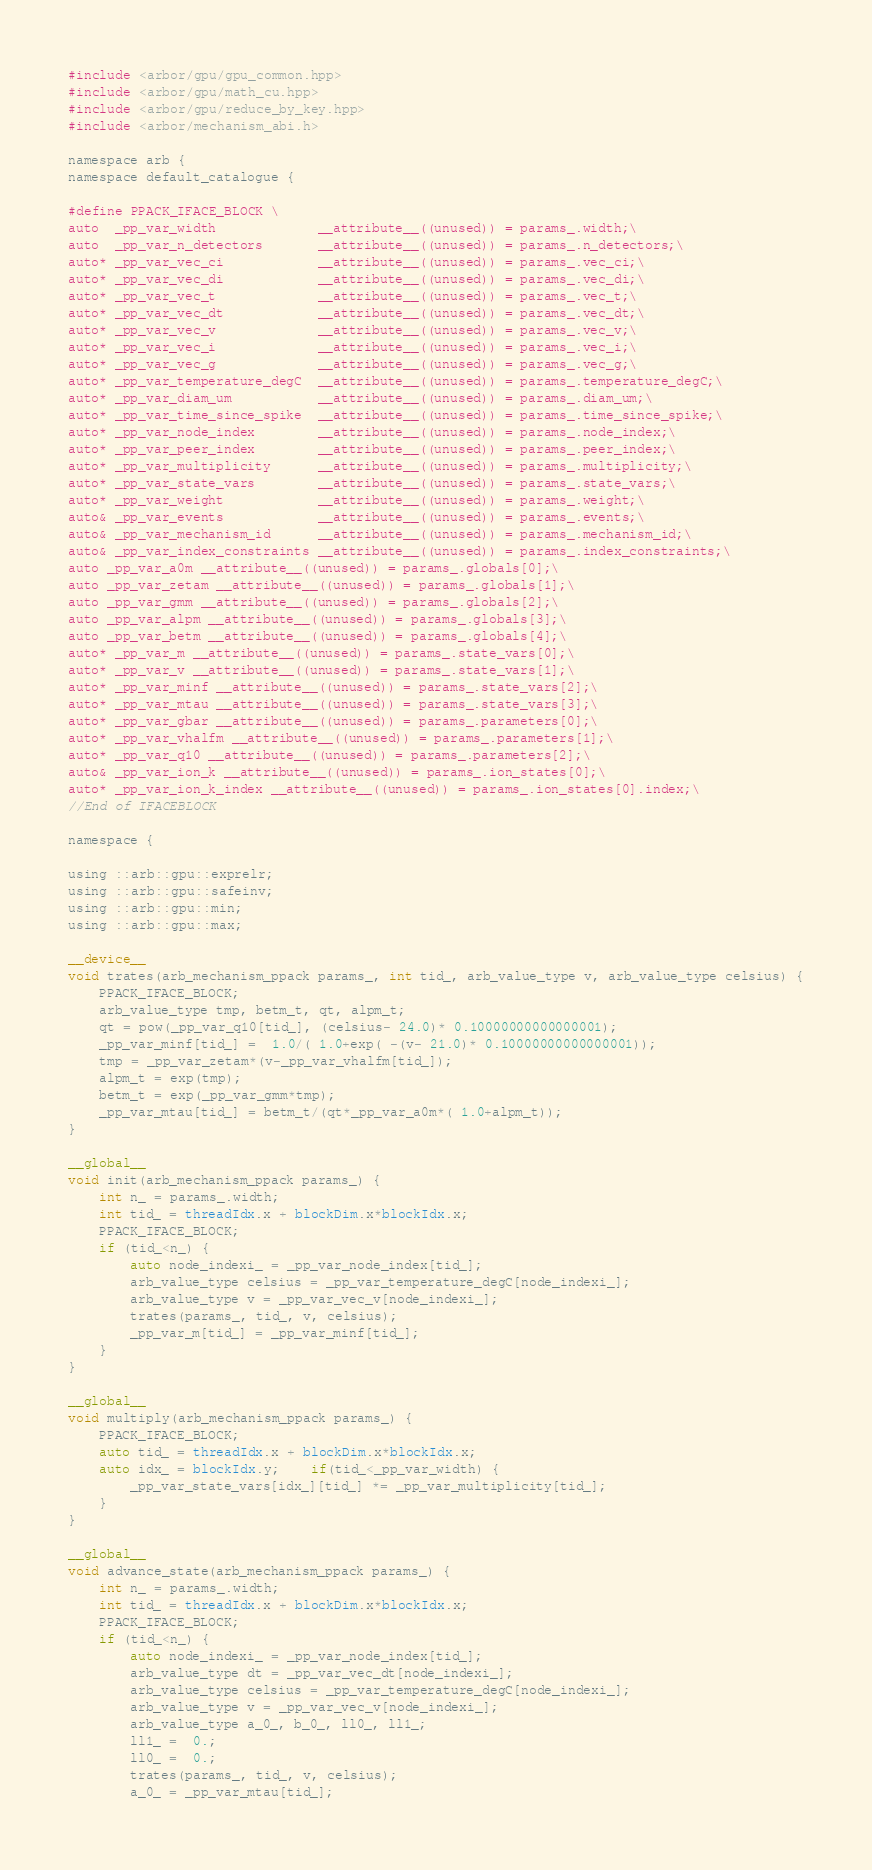<code> <loc_0><loc_0><loc_500><loc_500><_Cuda_>#include <arbor/gpu/gpu_common.hpp>
#include <arbor/gpu/math_cu.hpp>
#include <arbor/gpu/reduce_by_key.hpp>
#include <arbor/mechanism_abi.h>

namespace arb {
namespace default_catalogue {

#define PPACK_IFACE_BLOCK \
auto  _pp_var_width             __attribute__((unused)) = params_.width;\
auto  _pp_var_n_detectors       __attribute__((unused)) = params_.n_detectors;\
auto* _pp_var_vec_ci            __attribute__((unused)) = params_.vec_ci;\
auto* _pp_var_vec_di            __attribute__((unused)) = params_.vec_di;\
auto* _pp_var_vec_t             __attribute__((unused)) = params_.vec_t;\
auto* _pp_var_vec_dt            __attribute__((unused)) = params_.vec_dt;\
auto* _pp_var_vec_v             __attribute__((unused)) = params_.vec_v;\
auto* _pp_var_vec_i             __attribute__((unused)) = params_.vec_i;\
auto* _pp_var_vec_g             __attribute__((unused)) = params_.vec_g;\
auto* _pp_var_temperature_degC  __attribute__((unused)) = params_.temperature_degC;\
auto* _pp_var_diam_um           __attribute__((unused)) = params_.diam_um;\
auto* _pp_var_time_since_spike  __attribute__((unused)) = params_.time_since_spike;\
auto* _pp_var_node_index        __attribute__((unused)) = params_.node_index;\
auto* _pp_var_peer_index        __attribute__((unused)) = params_.peer_index;\
auto* _pp_var_multiplicity      __attribute__((unused)) = params_.multiplicity;\
auto* _pp_var_state_vars        __attribute__((unused)) = params_.state_vars;\
auto* _pp_var_weight            __attribute__((unused)) = params_.weight;\
auto& _pp_var_events            __attribute__((unused)) = params_.events;\
auto& _pp_var_mechanism_id      __attribute__((unused)) = params_.mechanism_id;\
auto& _pp_var_index_constraints __attribute__((unused)) = params_.index_constraints;\
auto _pp_var_a0m __attribute__((unused)) = params_.globals[0];\
auto _pp_var_zetam __attribute__((unused)) = params_.globals[1];\
auto _pp_var_gmm __attribute__((unused)) = params_.globals[2];\
auto _pp_var_alpm __attribute__((unused)) = params_.globals[3];\
auto _pp_var_betm __attribute__((unused)) = params_.globals[4];\
auto* _pp_var_m __attribute__((unused)) = params_.state_vars[0];\
auto* _pp_var_v __attribute__((unused)) = params_.state_vars[1];\
auto* _pp_var_minf __attribute__((unused)) = params_.state_vars[2];\
auto* _pp_var_mtau __attribute__((unused)) = params_.state_vars[3];\
auto* _pp_var_gbar __attribute__((unused)) = params_.parameters[0];\
auto* _pp_var_vhalfm __attribute__((unused)) = params_.parameters[1];\
auto* _pp_var_q10 __attribute__((unused)) = params_.parameters[2];\
auto& _pp_var_ion_k __attribute__((unused)) = params_.ion_states[0];\
auto* _pp_var_ion_k_index __attribute__((unused)) = params_.ion_states[0].index;\
//End of IFACEBLOCK

namespace {

using ::arb::gpu::exprelr;
using ::arb::gpu::safeinv;
using ::arb::gpu::min;
using ::arb::gpu::max;

__device__
void trates(arb_mechanism_ppack params_, int tid_, arb_value_type v, arb_value_type celsius) {
    PPACK_IFACE_BLOCK;
    arb_value_type tmp, betm_t, qt, alpm_t;
    qt = pow(_pp_var_q10[tid_], (celsius- 24.0)* 0.10000000000000001);
    _pp_var_minf[tid_] =  1.0/( 1.0+exp( -(v- 21.0)* 0.10000000000000001));
    tmp = _pp_var_zetam*(v-_pp_var_vhalfm[tid_]);
    alpm_t = exp(tmp);
    betm_t = exp(_pp_var_gmm*tmp);
    _pp_var_mtau[tid_] = betm_t/(qt*_pp_var_a0m*( 1.0+alpm_t));
}

__global__
void init(arb_mechanism_ppack params_) {
    int n_ = params_.width;
    int tid_ = threadIdx.x + blockDim.x*blockIdx.x;
    PPACK_IFACE_BLOCK;
    if (tid_<n_) {
        auto node_indexi_ = _pp_var_node_index[tid_];
        arb_value_type celsius = _pp_var_temperature_degC[node_indexi_];
        arb_value_type v = _pp_var_vec_v[node_indexi_];
        trates(params_, tid_, v, celsius);
        _pp_var_m[tid_] = _pp_var_minf[tid_];
    }
}

__global__
void multiply(arb_mechanism_ppack params_) {
    PPACK_IFACE_BLOCK;
    auto tid_ = threadIdx.x + blockDim.x*blockIdx.x;
    auto idx_ = blockIdx.y;    if(tid_<_pp_var_width) {
        _pp_var_state_vars[idx_][tid_] *= _pp_var_multiplicity[tid_];
    }
}

__global__
void advance_state(arb_mechanism_ppack params_) {
    int n_ = params_.width;
    int tid_ = threadIdx.x + blockDim.x*blockIdx.x;
    PPACK_IFACE_BLOCK;
    if (tid_<n_) {
        auto node_indexi_ = _pp_var_node_index[tid_];
        arb_value_type dt = _pp_var_vec_dt[node_indexi_];
        arb_value_type celsius = _pp_var_temperature_degC[node_indexi_];
        arb_value_type v = _pp_var_vec_v[node_indexi_];
        arb_value_type a_0_, b_0_, ll0_, ll1_;
        ll1_ =  0.;
        ll0_ =  0.;
        trates(params_, tid_, v, celsius);
        a_0_ = _pp_var_mtau[tid_];</code> 